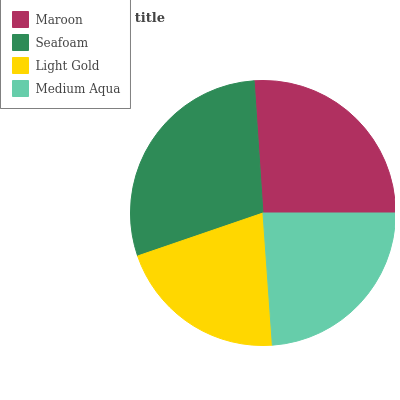Is Light Gold the minimum?
Answer yes or no. Yes. Is Seafoam the maximum?
Answer yes or no. Yes. Is Seafoam the minimum?
Answer yes or no. No. Is Light Gold the maximum?
Answer yes or no. No. Is Seafoam greater than Light Gold?
Answer yes or no. Yes. Is Light Gold less than Seafoam?
Answer yes or no. Yes. Is Light Gold greater than Seafoam?
Answer yes or no. No. Is Seafoam less than Light Gold?
Answer yes or no. No. Is Maroon the high median?
Answer yes or no. Yes. Is Medium Aqua the low median?
Answer yes or no. Yes. Is Medium Aqua the high median?
Answer yes or no. No. Is Maroon the low median?
Answer yes or no. No. 